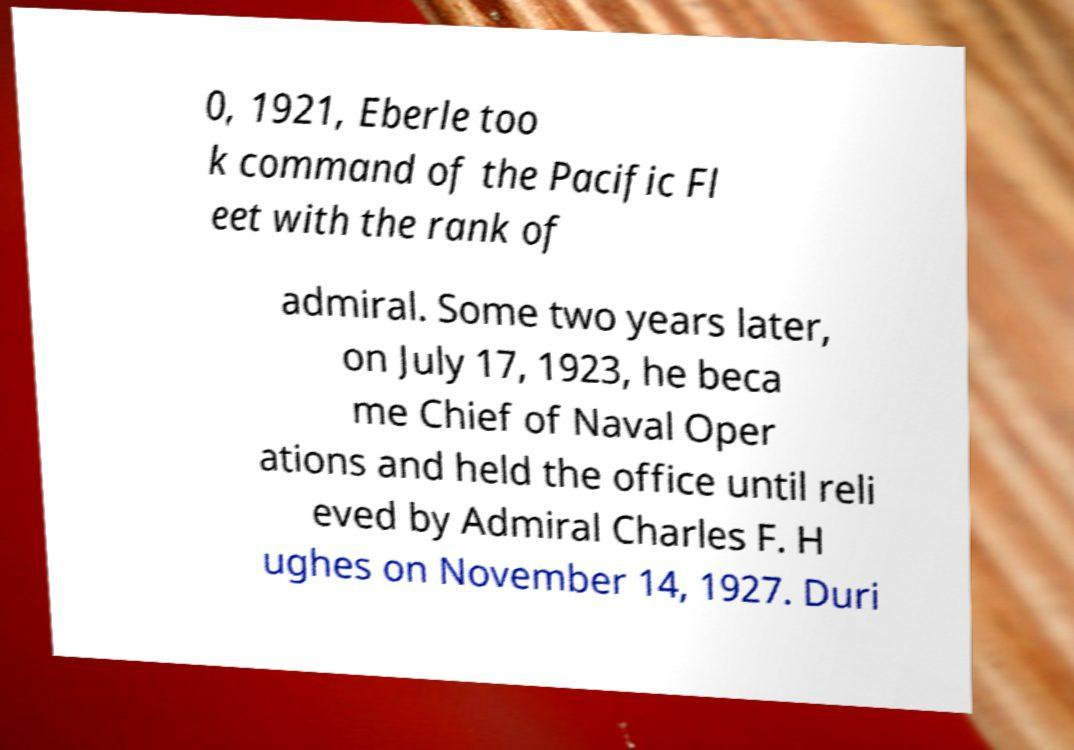There's text embedded in this image that I need extracted. Can you transcribe it verbatim? 0, 1921, Eberle too k command of the Pacific Fl eet with the rank of admiral. Some two years later, on July 17, 1923, he beca me Chief of Naval Oper ations and held the office until reli eved by Admiral Charles F. H ughes on November 14, 1927. Duri 